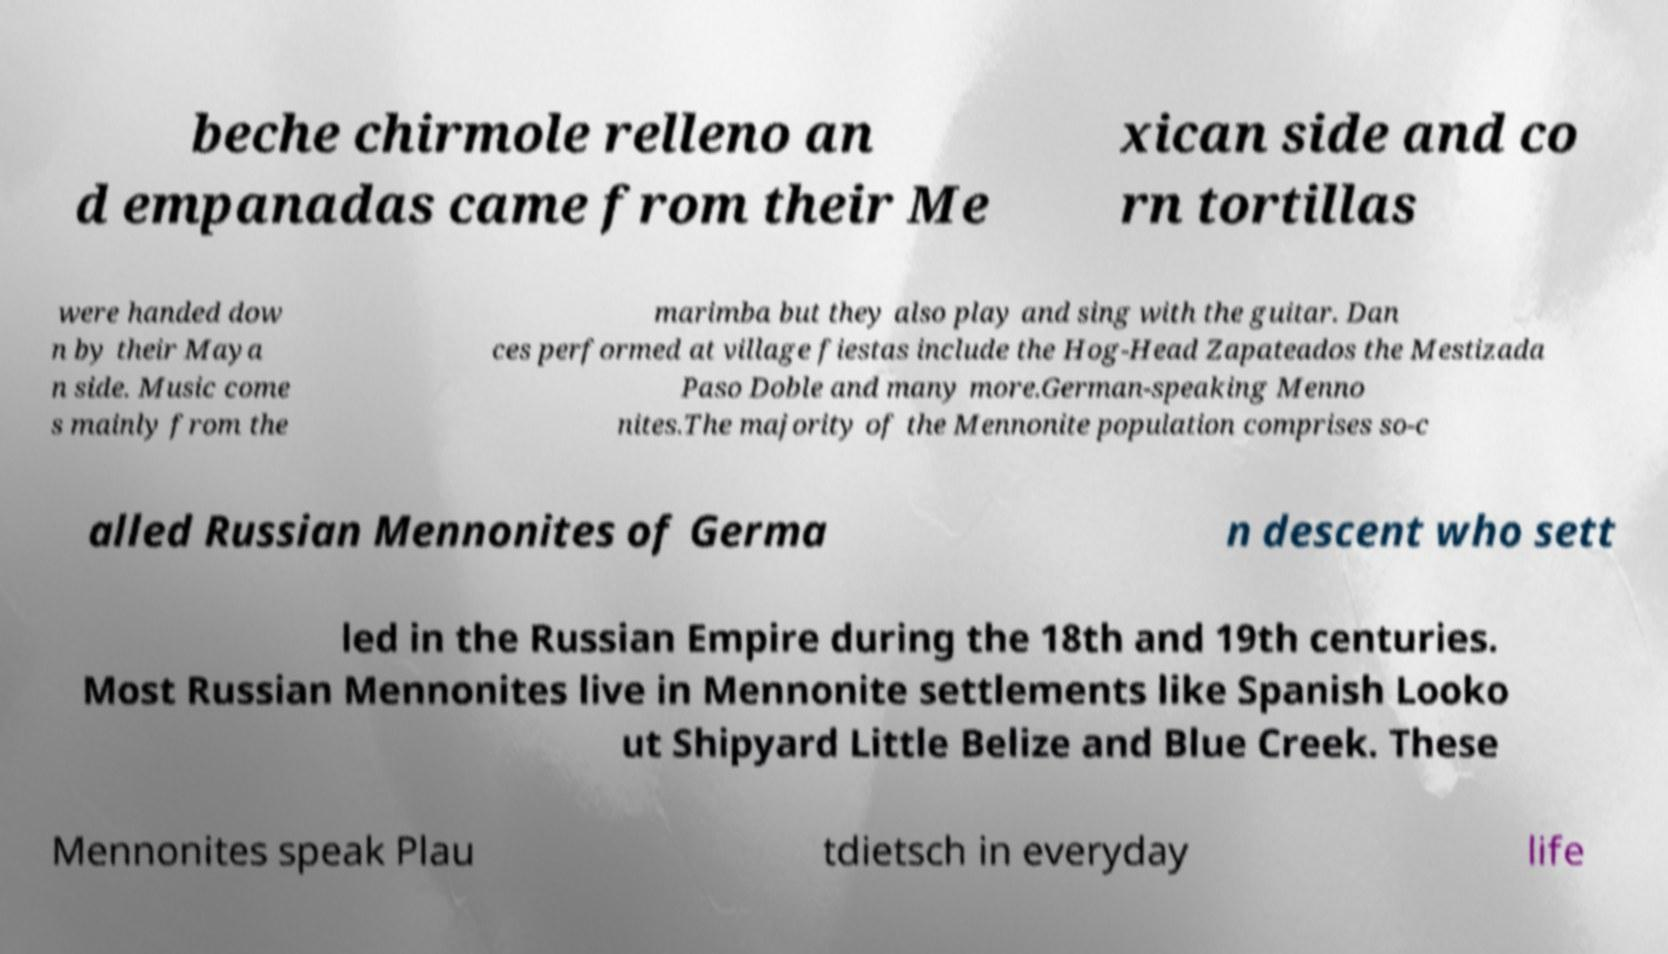Please identify and transcribe the text found in this image. beche chirmole relleno an d empanadas came from their Me xican side and co rn tortillas were handed dow n by their Maya n side. Music come s mainly from the marimba but they also play and sing with the guitar. Dan ces performed at village fiestas include the Hog-Head Zapateados the Mestizada Paso Doble and many more.German-speaking Menno nites.The majority of the Mennonite population comprises so-c alled Russian Mennonites of Germa n descent who sett led in the Russian Empire during the 18th and 19th centuries. Most Russian Mennonites live in Mennonite settlements like Spanish Looko ut Shipyard Little Belize and Blue Creek. These Mennonites speak Plau tdietsch in everyday life 